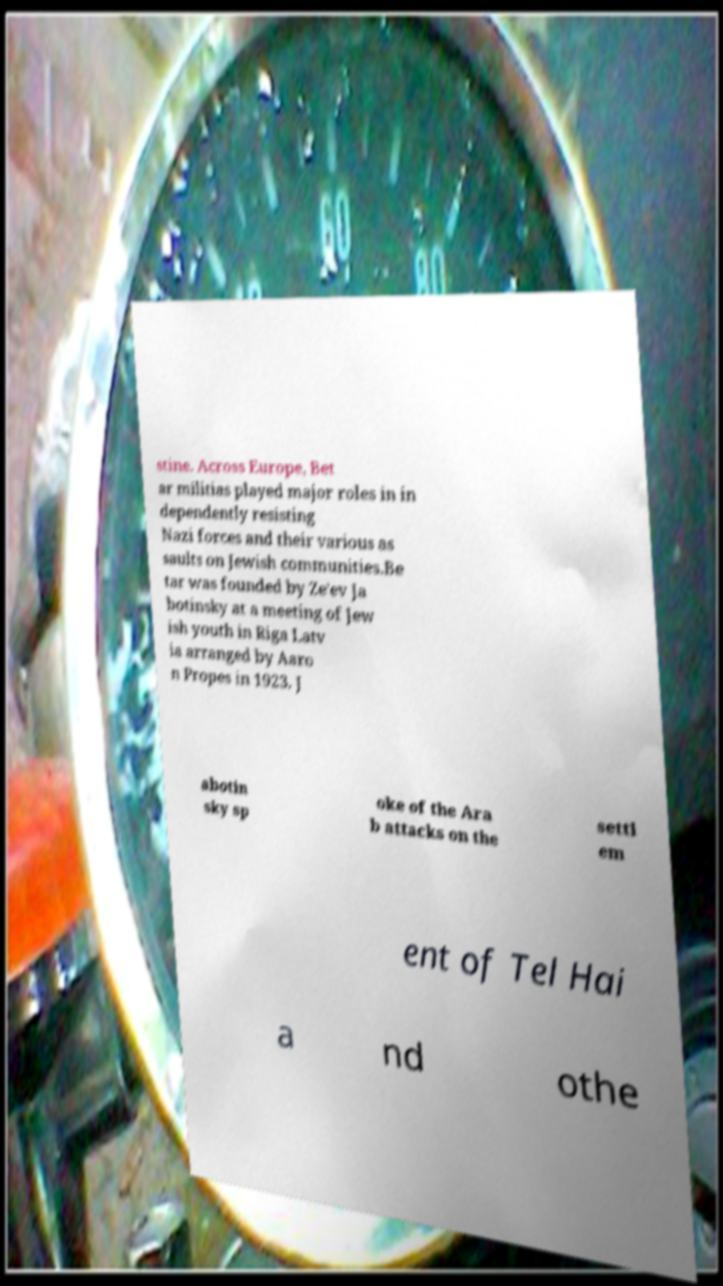For documentation purposes, I need the text within this image transcribed. Could you provide that? stine. Across Europe, Bet ar militias played major roles in in dependently resisting Nazi forces and their various as saults on Jewish communities.Be tar was founded by Ze'ev Ja botinsky at a meeting of Jew ish youth in Riga Latv ia arranged by Aaro n Propes in 1923. J abotin sky sp oke of the Ara b attacks on the settl em ent of Tel Hai a nd othe 